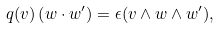Convert formula to latex. <formula><loc_0><loc_0><loc_500><loc_500>q ( v ) \left ( w \cdot w ^ { \prime } \right ) = \epsilon ( v \wedge w \wedge w ^ { \prime } ) ,</formula> 